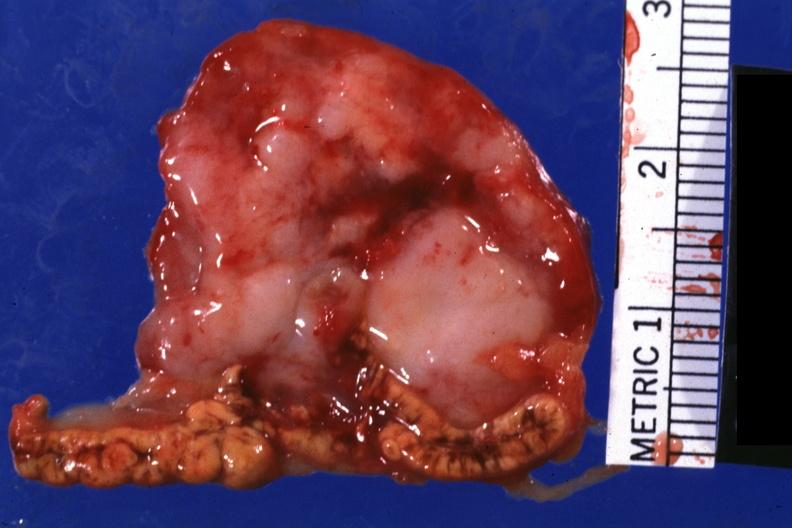what is present?
Answer the question using a single word or phrase. Endocrine 